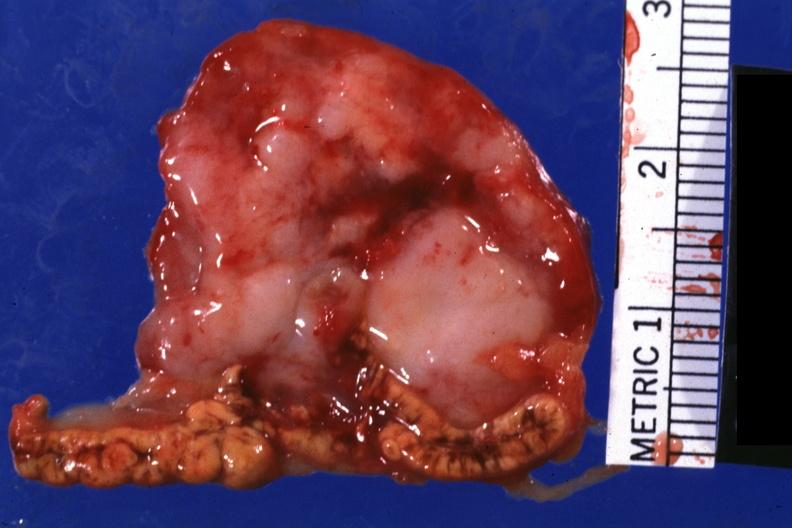what is present?
Answer the question using a single word or phrase. Endocrine 